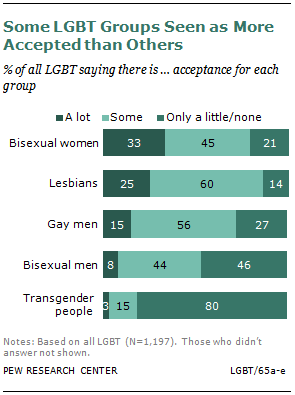Indicate a few pertinent items in this graphic. The average acceptance among all LGBT groups is 0.168. It is estimated that only 0.6% of people are accepted by some as being lesbian. 